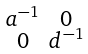<formula> <loc_0><loc_0><loc_500><loc_500>\begin{smallmatrix} a ^ { - 1 } & 0 \\ 0 & d ^ { - 1 } \end{smallmatrix}</formula> 